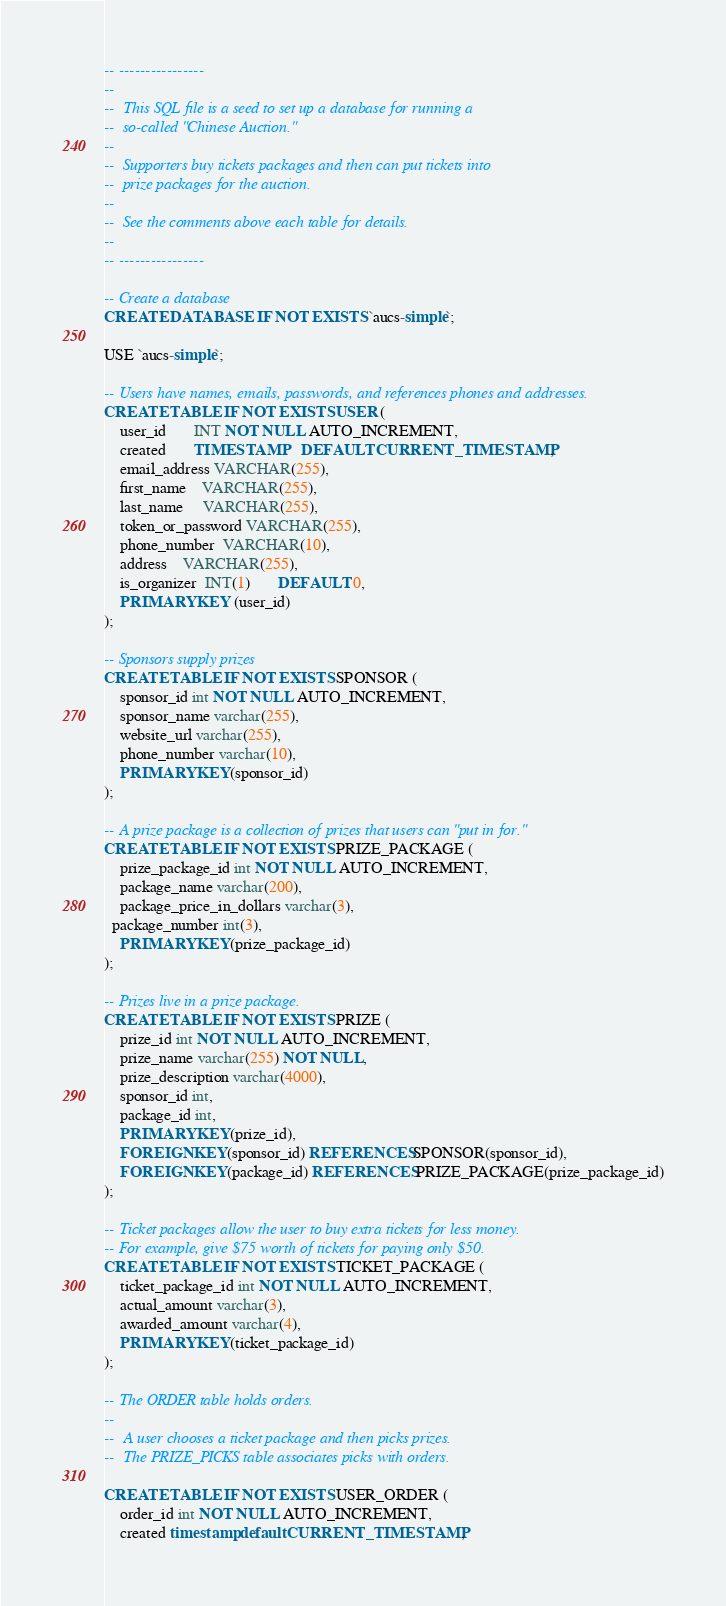Convert code to text. <code><loc_0><loc_0><loc_500><loc_500><_SQL_>-- ----------------
--
--	This SQL file is a seed to set up a database for running a 
--	so-called "Chinese Auction."
--
--	Supporters buy tickets packages and then can put tickets into
--	prize packages for the auction.
--
--	See the comments above each table for details.
--	
-- ----------------

-- Create a database
CREATE DATABASE IF NOT EXISTS `aucs-simple`;

USE `aucs-simple`;

-- Users have names, emails, passwords, and references phones and addresses.
CREATE TABLE IF NOT EXISTS USER (
	user_id       INT NOT NULL AUTO_INCREMENT,
	created       TIMESTAMP    DEFAULT CURRENT_TIMESTAMP,
	email_address VARCHAR(255),
	first_name    VARCHAR(255),
	last_name     VARCHAR(255),
	token_or_password VARCHAR(255),
	phone_number  VARCHAR(10),
	address	VARCHAR(255),
	is_organizer  INT(1)       DEFAULT 0,
	PRIMARY KEY (user_id)
);

-- Sponsors supply prizes
CREATE TABLE IF NOT EXISTS SPONSOR (
	sponsor_id int NOT NULL AUTO_INCREMENT,
	sponsor_name varchar(255),
	website_url varchar(255),
	phone_number varchar(10),
	PRIMARY KEY(sponsor_id)
);

-- A prize package is a collection of prizes that users can "put in for."
CREATE TABLE IF NOT EXISTS PRIZE_PACKAGE (
	prize_package_id int NOT NULL AUTO_INCREMENT,
	package_name varchar(200),
	package_price_in_dollars varchar(3),
  package_number int(3),
	PRIMARY KEY(prize_package_id)
);

-- Prizes live in a prize package.
CREATE TABLE IF NOT EXISTS PRIZE (
	prize_id int NOT NULL AUTO_INCREMENT,
	prize_name varchar(255) NOT NULL,
	prize_description varchar(4000),
	sponsor_id int,
	package_id int,
	PRIMARY KEY(prize_id),
	FOREIGN KEY(sponsor_id) REFERENCES SPONSOR(sponsor_id),
	FOREIGN KEY(package_id) REFERENCES PRIZE_PACKAGE(prize_package_id)
);

-- Ticket packages allow the user to buy extra tickets for less money.
-- For example, give $75 worth of tickets for paying only $50.
CREATE TABLE IF NOT EXISTS TICKET_PACKAGE (
	ticket_package_id int NOT NULL AUTO_INCREMENT,
	actual_amount varchar(3),
	awarded_amount varchar(4),
	PRIMARY KEY(ticket_package_id)
);

-- The ORDER table holds orders.
--
--	A user chooses a ticket package and then picks prizes.
--	The PRIZE_PICKS table associates picks with orders.

CREATE TABLE IF NOT EXISTS USER_ORDER (
	order_id int NOT NULL AUTO_INCREMENT,
	created timestamp default CURRENT_TIMESTAMP,</code> 